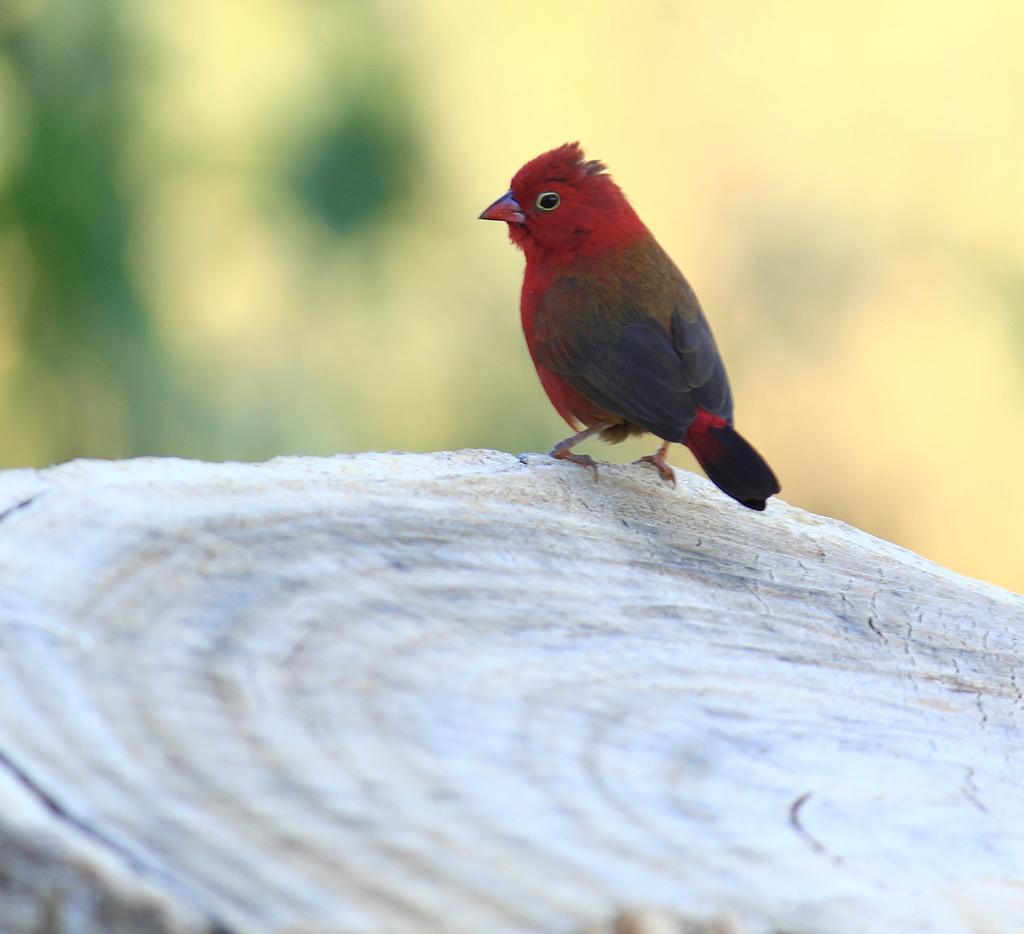Please provide a concise description of this image. In this picture I can see a bird on the wooden log, and there is blur background. 